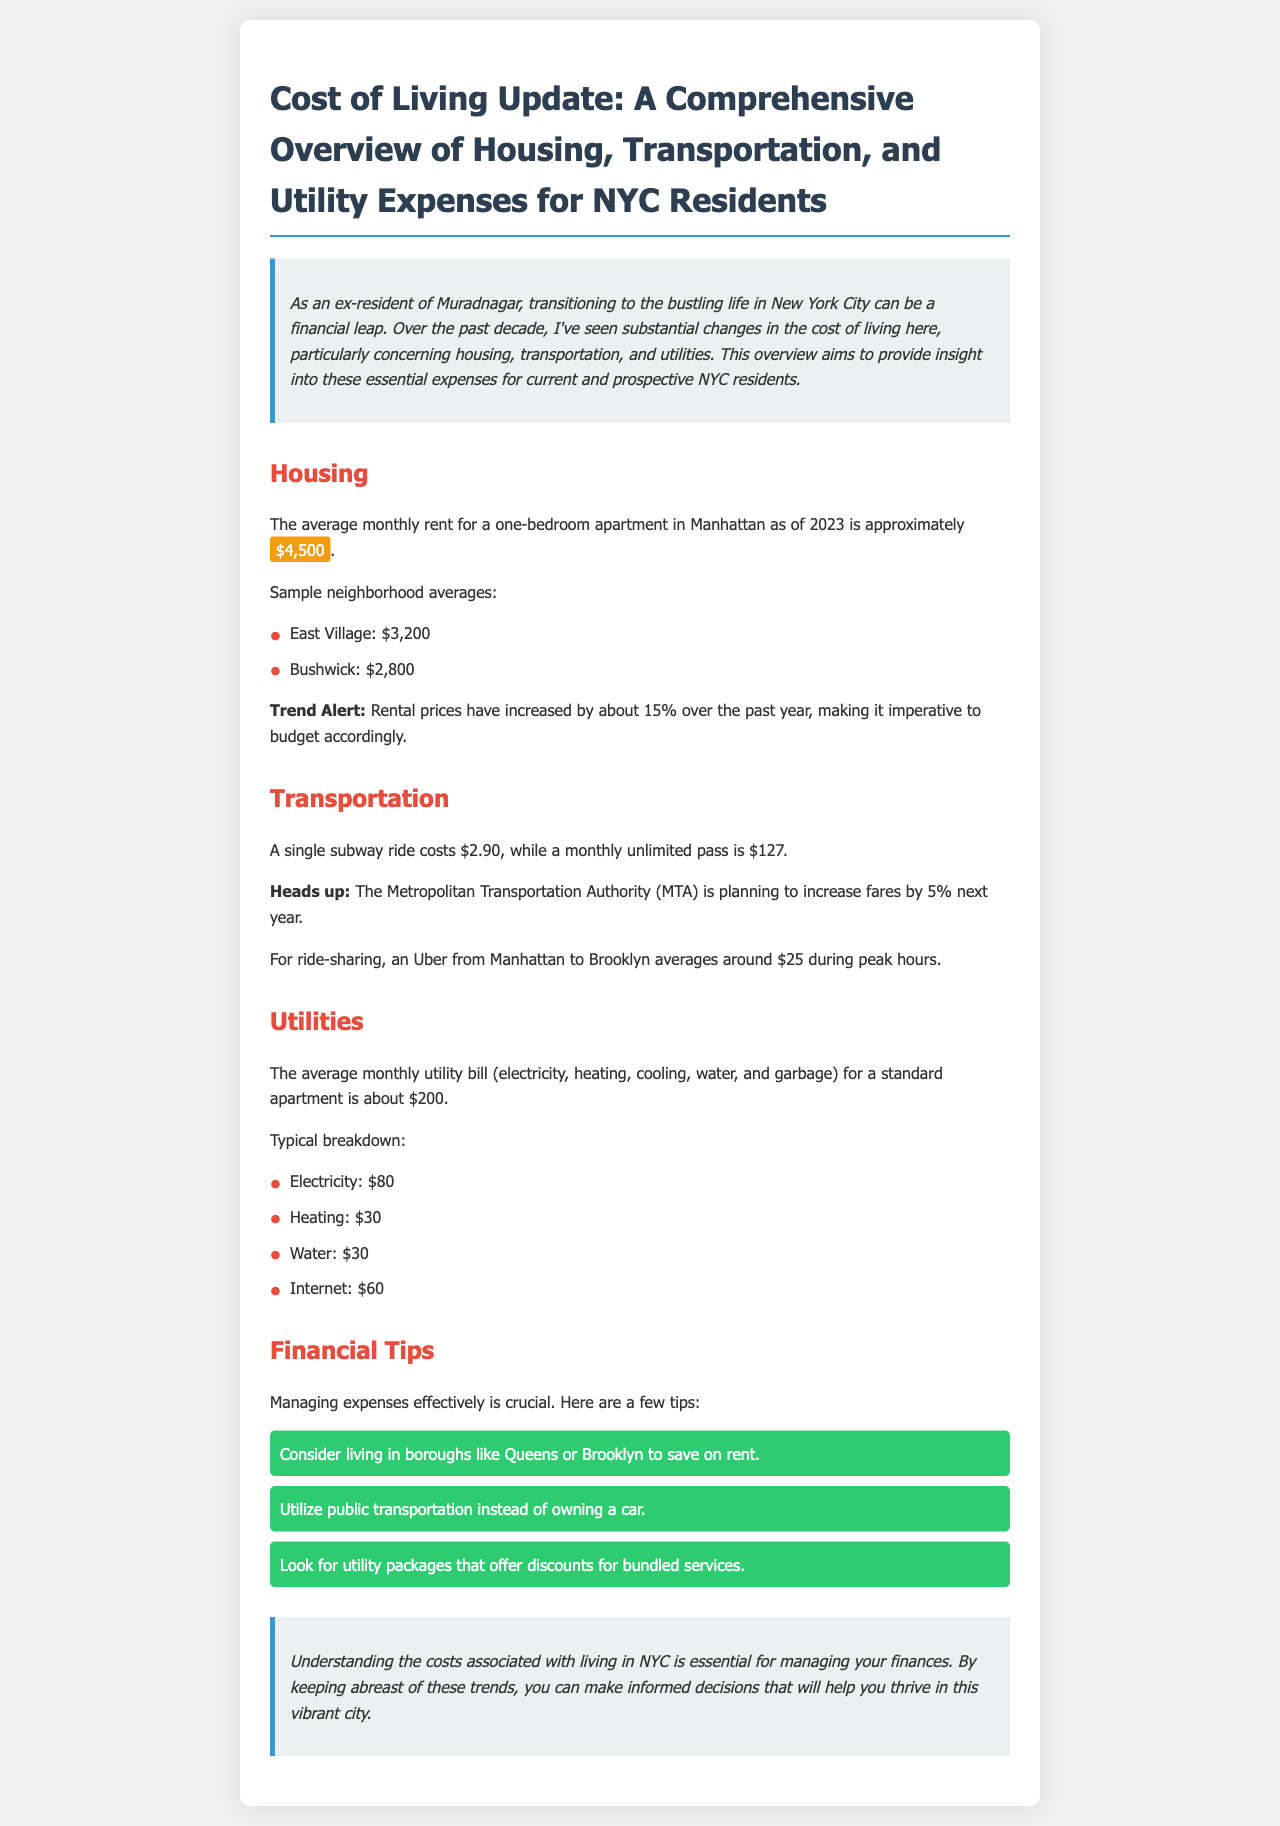What is the average monthly rent for a one-bedroom apartment in Manhattan? The document specifies that the average monthly rent for a one-bedroom apartment in Manhattan is approximately $4,500.
Answer: $4,500 What percentage have rental prices increased over the past year? It is mentioned in the document that rental prices have increased by about 15% over the past year.
Answer: 15% How much does a single subway ride cost? The cost of a single subway ride is stated as $2.90 in the document.
Answer: $2.90 What is the average monthly utility bill for a standard apartment? The document indicates that the average monthly utility bill for a standard apartment is about $200.
Answer: $200 What is a recommended way to save on rent? The newsletter suggests considering living in boroughs like Queens or Brooklyn to save on rent.
Answer: Boroughs like Queens or Brooklyn What is the cost of a monthly unlimited subway pass? According to the document, a monthly unlimited subway pass costs $127.
Answer: $127 What is highlighted as a future fare change by the MTA? The document notes that the Metropolitan Transportation Authority (MTA) is planning to increase fares by 5% next year.
Answer: 5% What utility service is estimated to cost $80 monthly? The document lists that electricity is estimated to cost about $80 monthly.
Answer: Electricity What advice is given regarding transportation? The newsletter advises utilizing public transportation instead of owning a car.
Answer: Utilize public transportation 